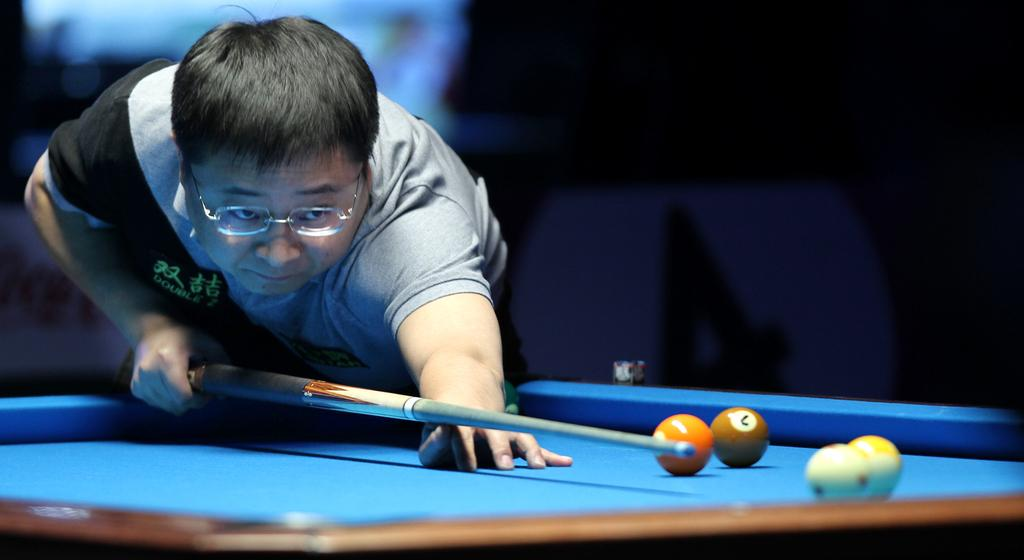What is the main subject of the image? There is a person in the image. What is the person holding in the image? The person is holding a stick. What activity is the person engaged in? The person is playing snookers. What objects are present on the table in the image? There are balls on the table. What direction is the person driving in the image? There is no vehicle or driving activity present in the image; the person is playing snookers. Can you hear any bells ringing in the image? There is no mention of bells or any sound in the image; it only shows a person playing snookers. 